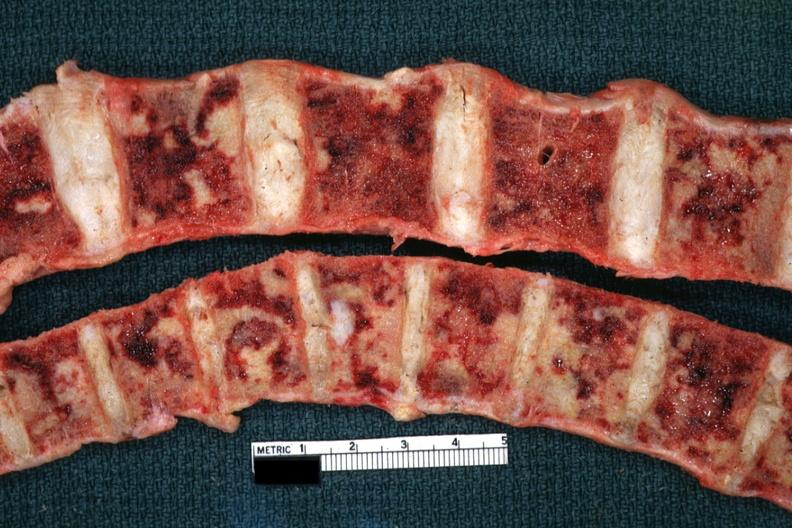does this image show multiple metastatic appearing lesions diagnosed reticulum cell sarcoma?
Answer the question using a single word or phrase. Yes 